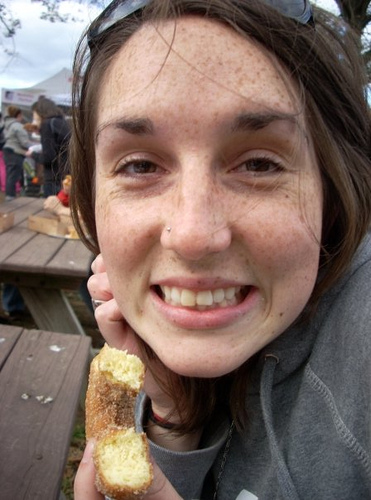Can you describe what the person is eating? The person appears to be eating a long, cylindrical food item that resembles a breadstick or garlic bread. It's golden-brown in color, suggesting it's been toasted or baked. 